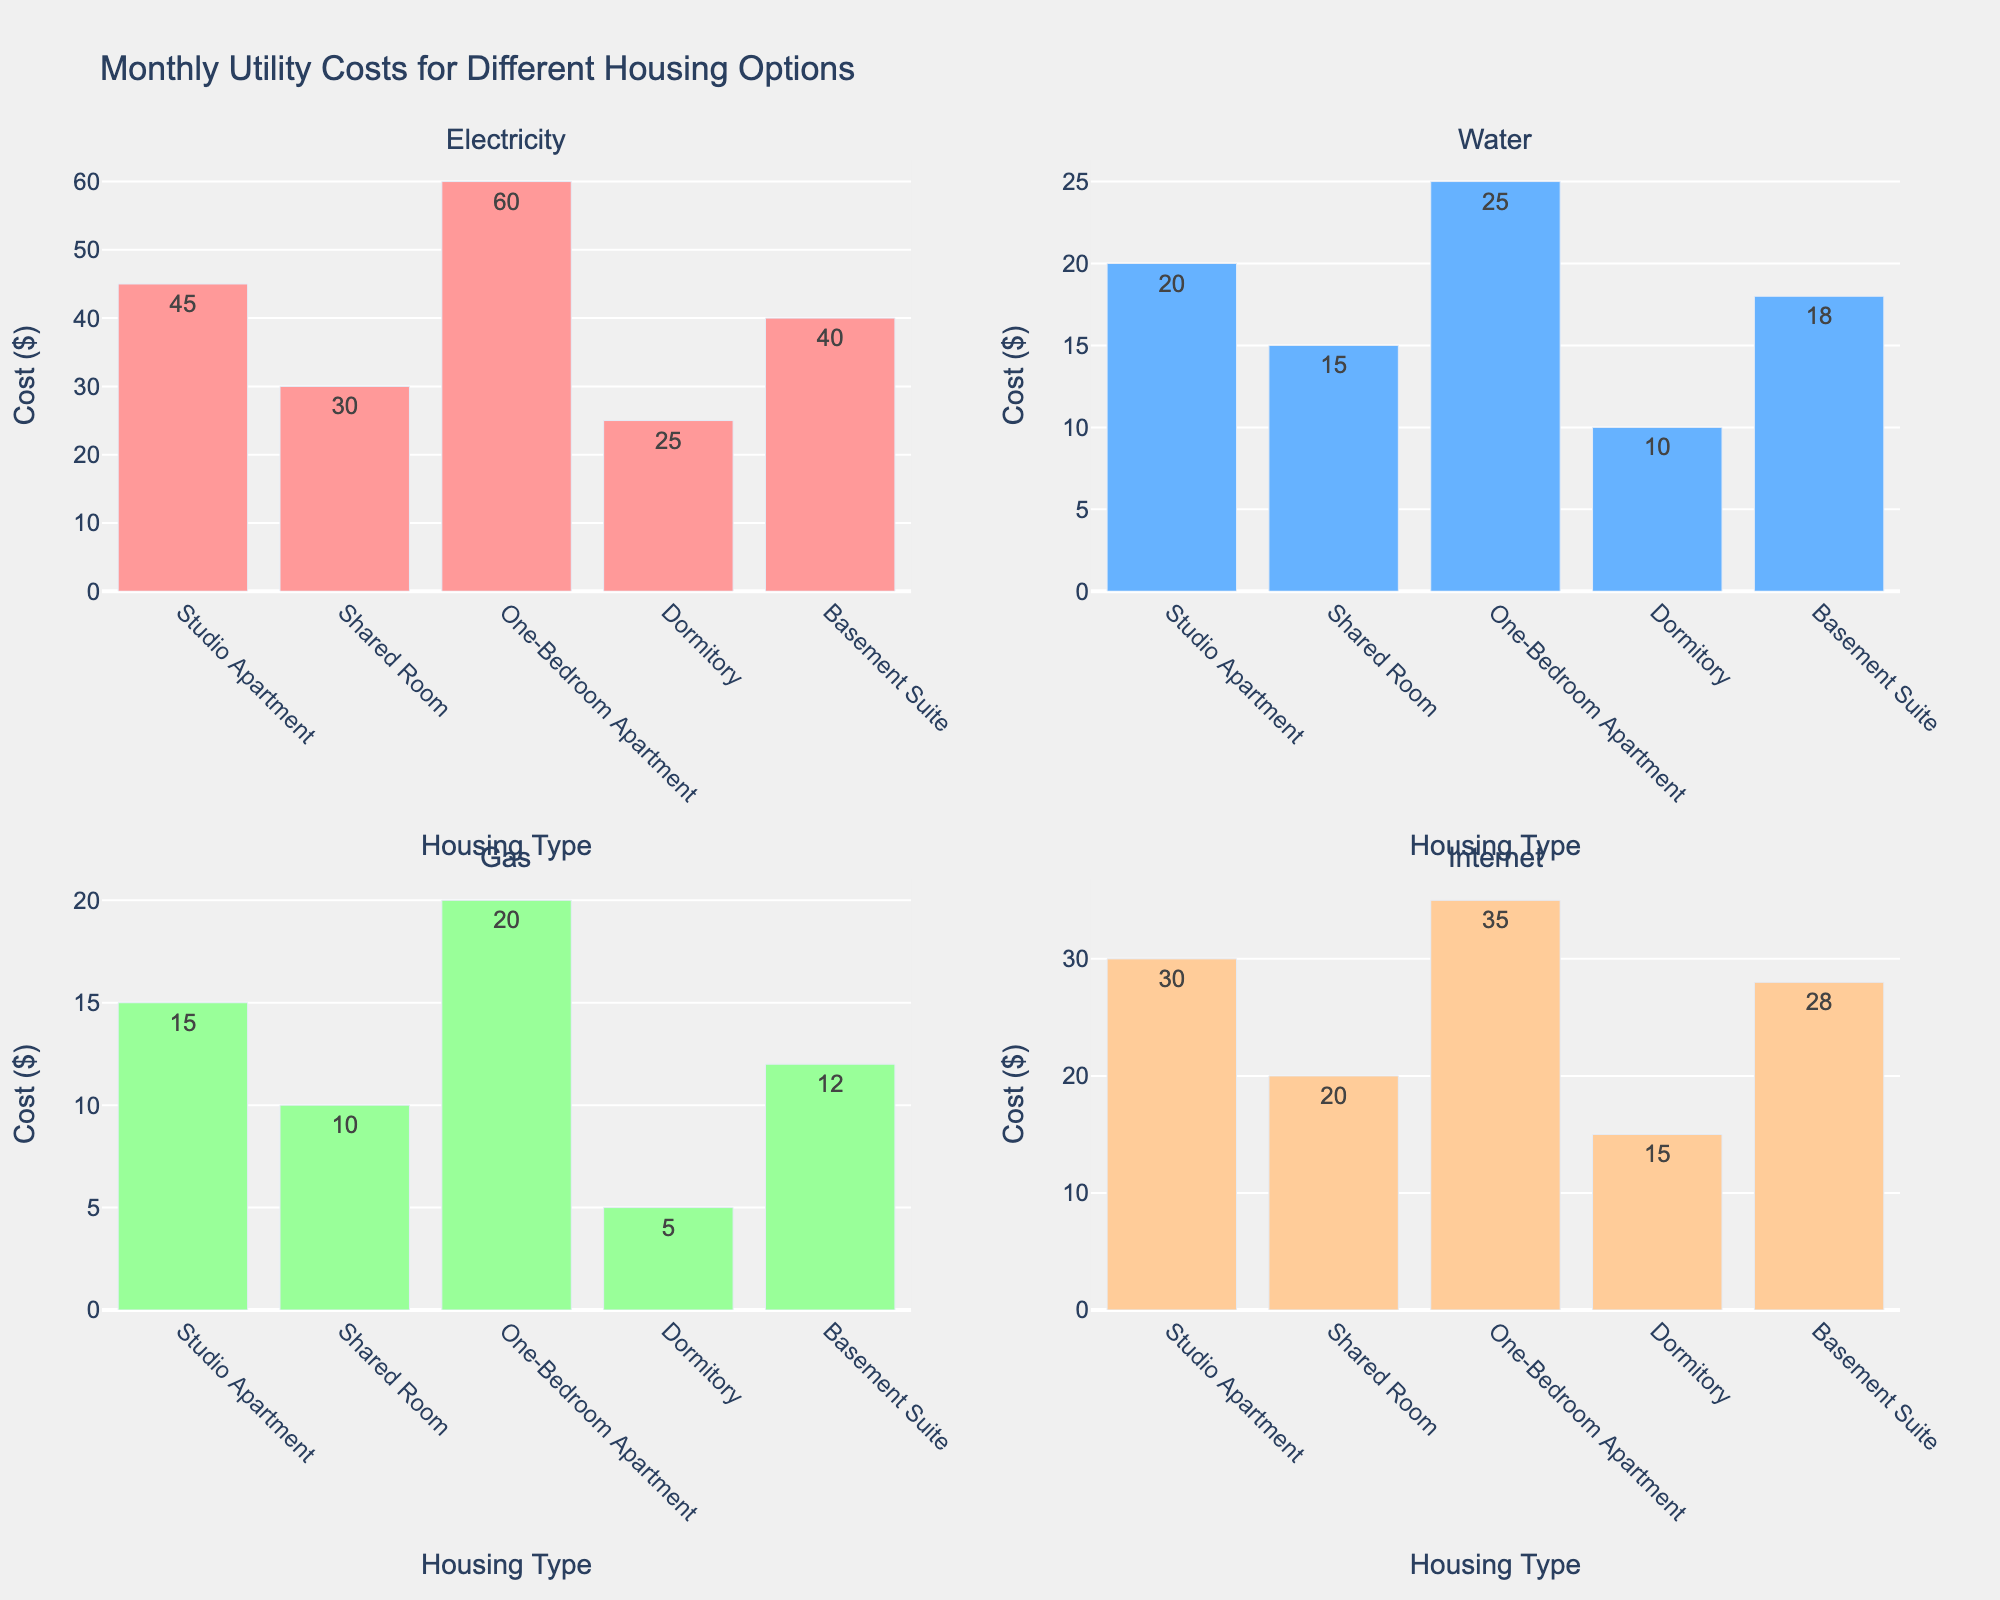What's the title of the figure? Look at the top area of the figure where the main title is located. The title describes the overall content of the figure.
Answer: "Monthly Utility Costs for Different Housing Options" What is the cost of electricity in a one-bedroom apartment? Refer to the subplot titled "Electricity" and locate the bar corresponding to "One-Bedroom Apartment". The cost value is displayed on top of the bar.
Answer: $60 Which utility has the highest cost across all housing types? Compare the highest values in all four subplots (Electricity, Water, Gas, Internet). The electricity subplot has the maximum value at $60 for the one-bedroom apartment.
Answer: Electricity How much is the total monthly cost for gas in all housing types? Sum up the values from the "Gas" subplot: Studio Apartment ($15) + Shared Room ($10) + One-Bedroom Apartment ($20) + Dormitory ($5) + Basement Suite ($12).
Answer: $62 Which housing type has the lowest water cost, and what is that cost? Refer to the "Water" subplot, identify the lowest bar, and note its cost and housing type. The lowest water cost is for the Dormitory.
Answer: Dormitory, $10 What’s the average internet cost across all housing types? Sum the internet costs from the "Internet" subplot and divide by the number of housing types: (30 + 20 + 35 + 15 + 28) / 5. Calculate the average.
Answer: $25.6 Which utility has the simplest structure (least complex subplot)? Identify the subplot with the bars displaying the fewest cost differences. The "Gas" subplot has values closer to each other (5, 10, 12, 15, 20) compared to electricity, water, and internet.
Answer: Gas 